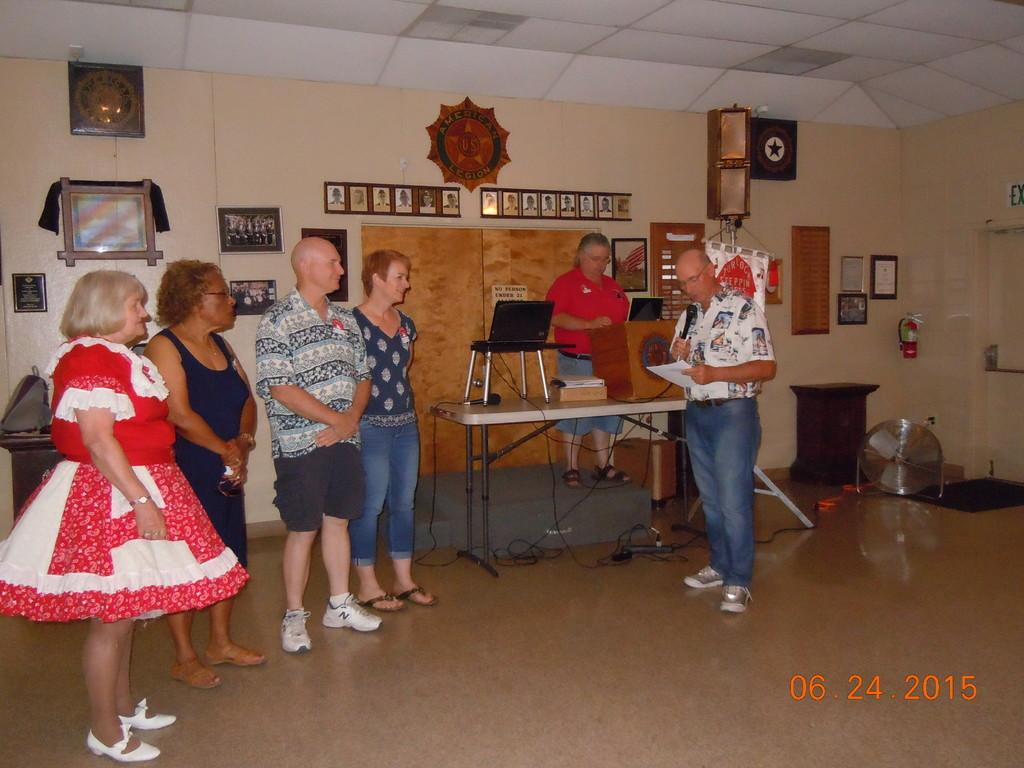How many people are present in the image? There are six people standing in the image. What object can be seen on a table in the image? There is a laptop on a table in the image. What is one person holding in the image? One person is holding a mic in the image. What is another person holding in the image? One person is holding a paper in the image. What can be seen at the back side of the image? There are frames visible at the back side of the image. What type of bear can be seen sitting on a plate in the image? There is no bear or plate present in the image. How does the wealth of the people in the image compare to each other? The provided facts do not give any information about the wealth of the people in the image, so it cannot be determined. 